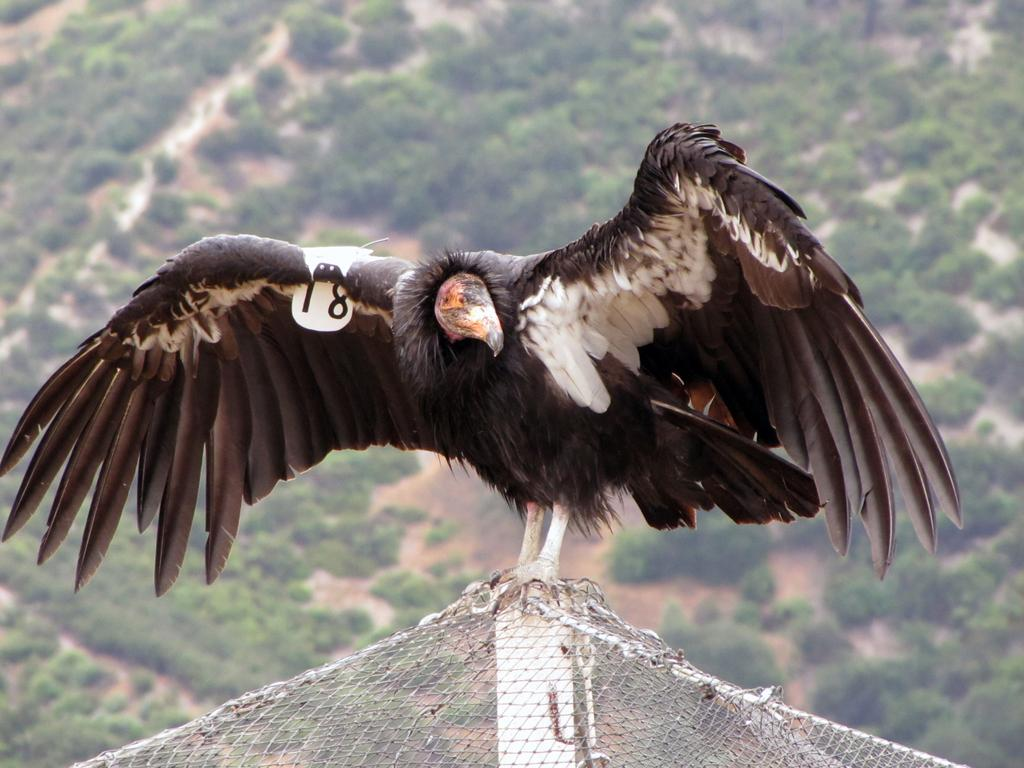What is on top of the pole in the image? There is a bird on a pole in the image. What object is present to potentially catch or contain something in the image? There is a net visible in the image. What type of surface can be seen at the bottom of the image? There is ground visible in the image. What type of vegetation is present on the ground in the image? There are plants on the ground in the image. What type of mist can be seen surrounding the bird in the image? There is no mist present in the image; the bird is clearly visible on the pole. 